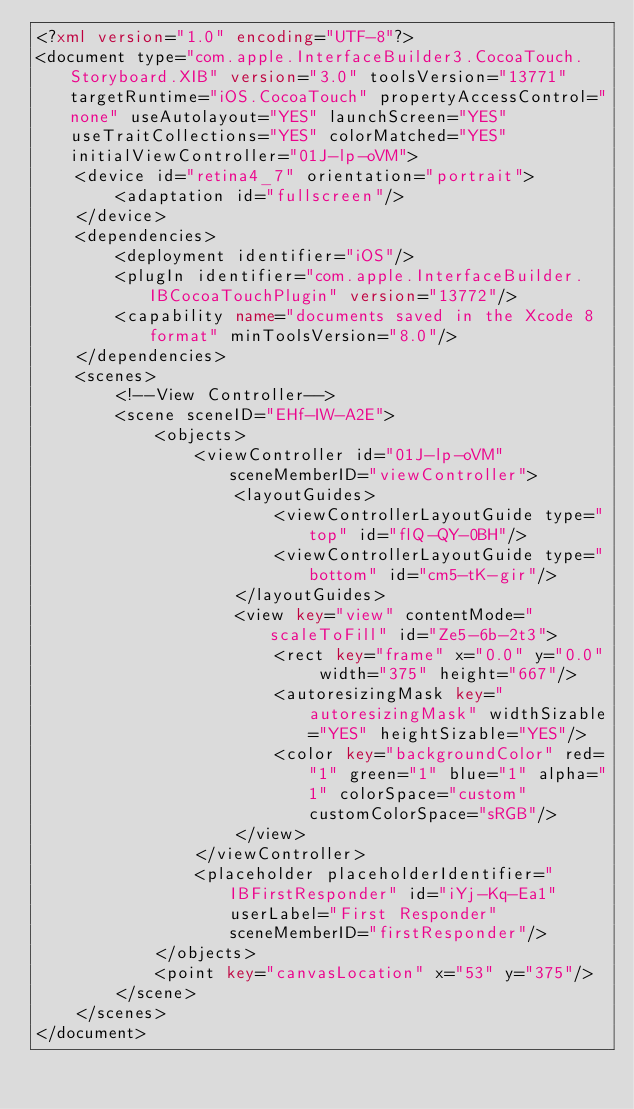Convert code to text. <code><loc_0><loc_0><loc_500><loc_500><_XML_><?xml version="1.0" encoding="UTF-8"?>
<document type="com.apple.InterfaceBuilder3.CocoaTouch.Storyboard.XIB" version="3.0" toolsVersion="13771" targetRuntime="iOS.CocoaTouch" propertyAccessControl="none" useAutolayout="YES" launchScreen="YES" useTraitCollections="YES" colorMatched="YES" initialViewController="01J-lp-oVM">
    <device id="retina4_7" orientation="portrait">
        <adaptation id="fullscreen"/>
    </device>
    <dependencies>
        <deployment identifier="iOS"/>
        <plugIn identifier="com.apple.InterfaceBuilder.IBCocoaTouchPlugin" version="13772"/>
        <capability name="documents saved in the Xcode 8 format" minToolsVersion="8.0"/>
    </dependencies>
    <scenes>
        <!--View Controller-->
        <scene sceneID="EHf-IW-A2E">
            <objects>
                <viewController id="01J-lp-oVM" sceneMemberID="viewController">
                    <layoutGuides>
                        <viewControllerLayoutGuide type="top" id="flQ-QY-0BH"/>
                        <viewControllerLayoutGuide type="bottom" id="cm5-tK-gir"/>
                    </layoutGuides>
                    <view key="view" contentMode="scaleToFill" id="Ze5-6b-2t3">
                        <rect key="frame" x="0.0" y="0.0" width="375" height="667"/>
                        <autoresizingMask key="autoresizingMask" widthSizable="YES" heightSizable="YES"/>
                        <color key="backgroundColor" red="1" green="1" blue="1" alpha="1" colorSpace="custom" customColorSpace="sRGB"/>
                    </view>
                </viewController>
                <placeholder placeholderIdentifier="IBFirstResponder" id="iYj-Kq-Ea1" userLabel="First Responder" sceneMemberID="firstResponder"/>
            </objects>
            <point key="canvasLocation" x="53" y="375"/>
        </scene>
    </scenes>
</document>
</code> 